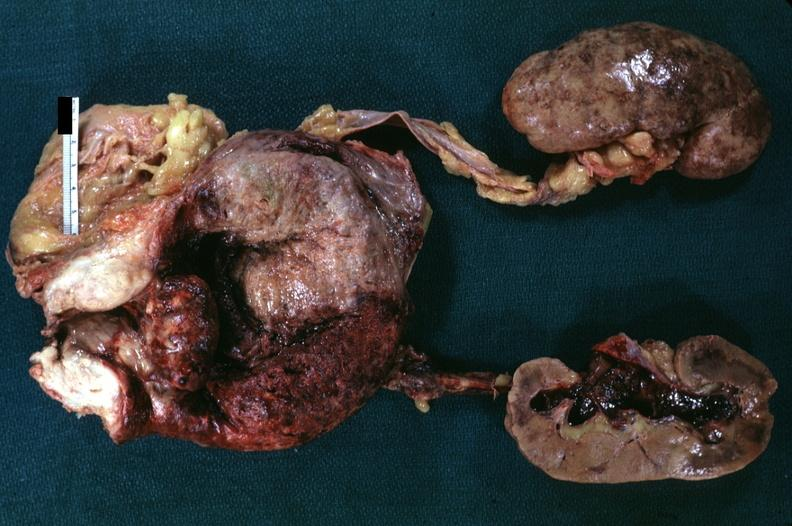what is diagnosis?
Answer the question using a single word or phrase. Pyelonephritis carcinoma in prostate 